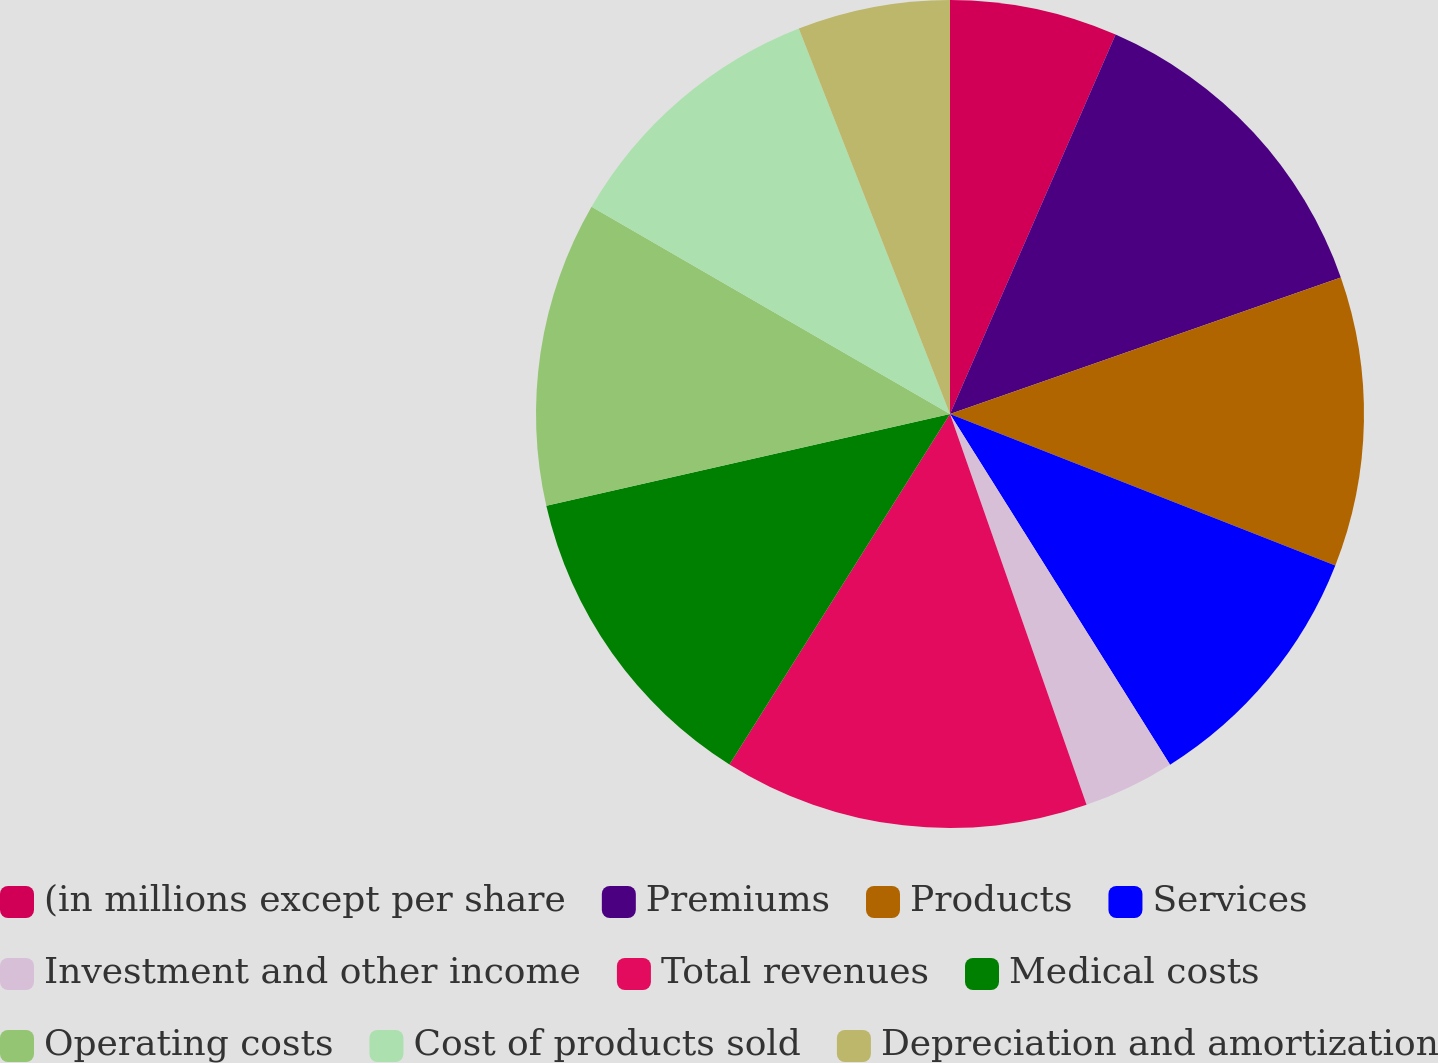Convert chart. <chart><loc_0><loc_0><loc_500><loc_500><pie_chart><fcel>(in millions except per share<fcel>Premiums<fcel>Products<fcel>Services<fcel>Investment and other income<fcel>Total revenues<fcel>Medical costs<fcel>Operating costs<fcel>Cost of products sold<fcel>Depreciation and amortization<nl><fcel>6.55%<fcel>13.1%<fcel>11.31%<fcel>10.12%<fcel>3.57%<fcel>14.29%<fcel>12.5%<fcel>11.9%<fcel>10.71%<fcel>5.95%<nl></chart> 